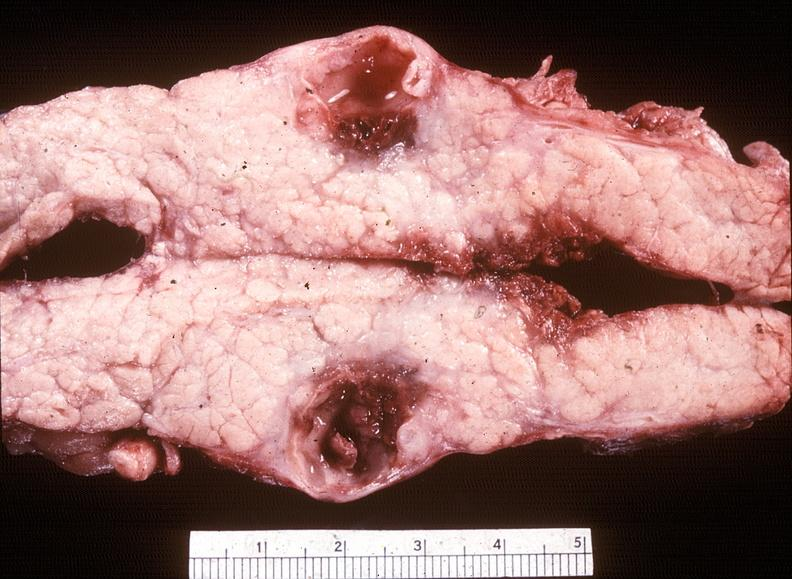what does this image show?
Answer the question using a single word or phrase. Chronic pancreatitis with cyst formation 